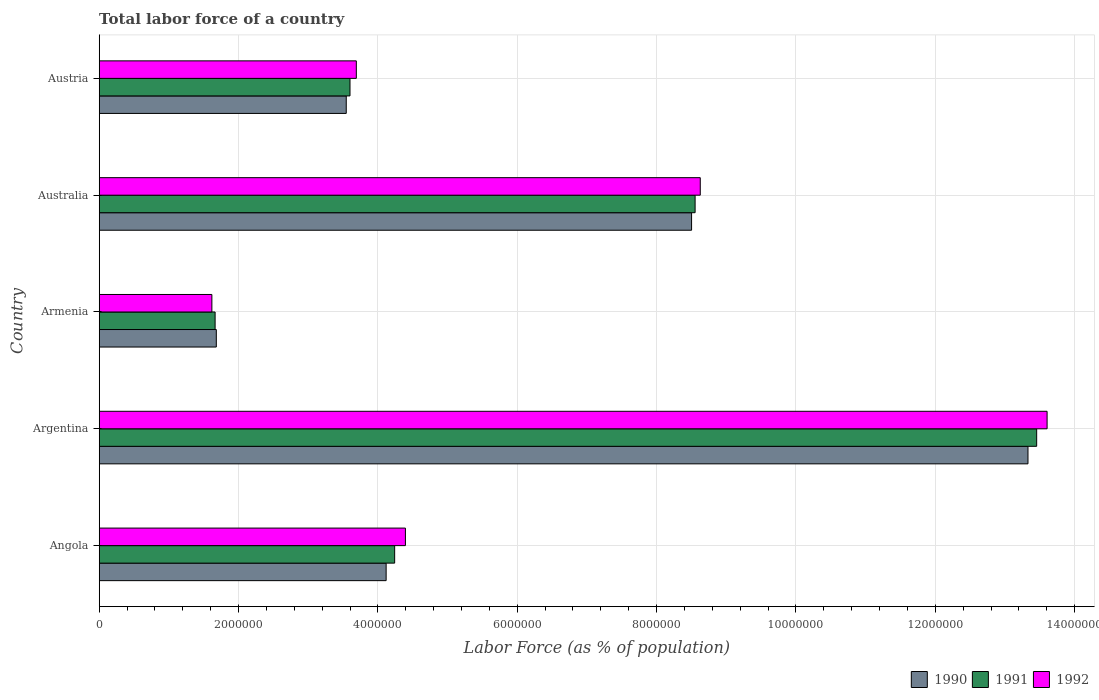Are the number of bars on each tick of the Y-axis equal?
Your answer should be compact. Yes. How many bars are there on the 4th tick from the top?
Ensure brevity in your answer.  3. What is the label of the 4th group of bars from the top?
Your answer should be very brief. Argentina. What is the percentage of labor force in 1991 in Angola?
Give a very brief answer. 4.24e+06. Across all countries, what is the maximum percentage of labor force in 1991?
Your answer should be very brief. 1.35e+07. Across all countries, what is the minimum percentage of labor force in 1992?
Offer a very short reply. 1.62e+06. In which country was the percentage of labor force in 1990 minimum?
Offer a very short reply. Armenia. What is the total percentage of labor force in 1991 in the graph?
Ensure brevity in your answer.  3.15e+07. What is the difference between the percentage of labor force in 1992 in Argentina and that in Australia?
Keep it short and to the point. 4.98e+06. What is the difference between the percentage of labor force in 1990 in Argentina and the percentage of labor force in 1991 in Angola?
Your answer should be very brief. 9.09e+06. What is the average percentage of labor force in 1992 per country?
Make the answer very short. 6.39e+06. What is the difference between the percentage of labor force in 1992 and percentage of labor force in 1991 in Angola?
Offer a very short reply. 1.55e+05. What is the ratio of the percentage of labor force in 1991 in Armenia to that in Austria?
Ensure brevity in your answer.  0.46. Is the percentage of labor force in 1990 in Australia less than that in Austria?
Provide a short and direct response. No. What is the difference between the highest and the second highest percentage of labor force in 1991?
Give a very brief answer. 4.90e+06. What is the difference between the highest and the lowest percentage of labor force in 1990?
Ensure brevity in your answer.  1.17e+07. What does the 2nd bar from the top in Angola represents?
Your response must be concise. 1991. What does the 2nd bar from the bottom in Armenia represents?
Keep it short and to the point. 1991. Is it the case that in every country, the sum of the percentage of labor force in 1990 and percentage of labor force in 1991 is greater than the percentage of labor force in 1992?
Provide a succinct answer. Yes. Are all the bars in the graph horizontal?
Make the answer very short. Yes. Are the values on the major ticks of X-axis written in scientific E-notation?
Provide a succinct answer. No. Does the graph contain any zero values?
Keep it short and to the point. No. How many legend labels are there?
Your answer should be very brief. 3. How are the legend labels stacked?
Your response must be concise. Horizontal. What is the title of the graph?
Offer a terse response. Total labor force of a country. Does "1973" appear as one of the legend labels in the graph?
Keep it short and to the point. No. What is the label or title of the X-axis?
Give a very brief answer. Labor Force (as % of population). What is the label or title of the Y-axis?
Provide a short and direct response. Country. What is the Labor Force (as % of population) in 1990 in Angola?
Offer a very short reply. 4.12e+06. What is the Labor Force (as % of population) in 1991 in Angola?
Your answer should be very brief. 4.24e+06. What is the Labor Force (as % of population) in 1992 in Angola?
Give a very brief answer. 4.40e+06. What is the Labor Force (as % of population) of 1990 in Argentina?
Provide a succinct answer. 1.33e+07. What is the Labor Force (as % of population) in 1991 in Argentina?
Offer a terse response. 1.35e+07. What is the Labor Force (as % of population) of 1992 in Argentina?
Your answer should be compact. 1.36e+07. What is the Labor Force (as % of population) in 1990 in Armenia?
Make the answer very short. 1.68e+06. What is the Labor Force (as % of population) of 1991 in Armenia?
Your answer should be very brief. 1.66e+06. What is the Labor Force (as % of population) in 1992 in Armenia?
Offer a very short reply. 1.62e+06. What is the Labor Force (as % of population) of 1990 in Australia?
Give a very brief answer. 8.50e+06. What is the Labor Force (as % of population) of 1991 in Australia?
Offer a very short reply. 8.55e+06. What is the Labor Force (as % of population) of 1992 in Australia?
Your response must be concise. 8.63e+06. What is the Labor Force (as % of population) of 1990 in Austria?
Your answer should be compact. 3.55e+06. What is the Labor Force (as % of population) in 1991 in Austria?
Your response must be concise. 3.60e+06. What is the Labor Force (as % of population) in 1992 in Austria?
Give a very brief answer. 3.69e+06. Across all countries, what is the maximum Labor Force (as % of population) of 1990?
Your response must be concise. 1.33e+07. Across all countries, what is the maximum Labor Force (as % of population) in 1991?
Offer a very short reply. 1.35e+07. Across all countries, what is the maximum Labor Force (as % of population) of 1992?
Offer a terse response. 1.36e+07. Across all countries, what is the minimum Labor Force (as % of population) in 1990?
Your answer should be compact. 1.68e+06. Across all countries, what is the minimum Labor Force (as % of population) of 1991?
Provide a short and direct response. 1.66e+06. Across all countries, what is the minimum Labor Force (as % of population) in 1992?
Provide a short and direct response. 1.62e+06. What is the total Labor Force (as % of population) in 1990 in the graph?
Your answer should be compact. 3.12e+07. What is the total Labor Force (as % of population) of 1991 in the graph?
Your answer should be very brief. 3.15e+07. What is the total Labor Force (as % of population) in 1992 in the graph?
Offer a terse response. 3.19e+07. What is the difference between the Labor Force (as % of population) of 1990 in Angola and that in Argentina?
Offer a very short reply. -9.21e+06. What is the difference between the Labor Force (as % of population) of 1991 in Angola and that in Argentina?
Your answer should be compact. -9.21e+06. What is the difference between the Labor Force (as % of population) of 1992 in Angola and that in Argentina?
Offer a terse response. -9.21e+06. What is the difference between the Labor Force (as % of population) in 1990 in Angola and that in Armenia?
Offer a terse response. 2.44e+06. What is the difference between the Labor Force (as % of population) of 1991 in Angola and that in Armenia?
Ensure brevity in your answer.  2.58e+06. What is the difference between the Labor Force (as % of population) in 1992 in Angola and that in Armenia?
Provide a succinct answer. 2.78e+06. What is the difference between the Labor Force (as % of population) in 1990 in Angola and that in Australia?
Give a very brief answer. -4.38e+06. What is the difference between the Labor Force (as % of population) of 1991 in Angola and that in Australia?
Your response must be concise. -4.31e+06. What is the difference between the Labor Force (as % of population) of 1992 in Angola and that in Australia?
Your answer should be very brief. -4.23e+06. What is the difference between the Labor Force (as % of population) in 1990 in Angola and that in Austria?
Ensure brevity in your answer.  5.73e+05. What is the difference between the Labor Force (as % of population) of 1991 in Angola and that in Austria?
Your answer should be very brief. 6.41e+05. What is the difference between the Labor Force (as % of population) in 1992 in Angola and that in Austria?
Your answer should be compact. 7.05e+05. What is the difference between the Labor Force (as % of population) in 1990 in Argentina and that in Armenia?
Ensure brevity in your answer.  1.17e+07. What is the difference between the Labor Force (as % of population) in 1991 in Argentina and that in Armenia?
Provide a short and direct response. 1.18e+07. What is the difference between the Labor Force (as % of population) of 1992 in Argentina and that in Armenia?
Your answer should be very brief. 1.20e+07. What is the difference between the Labor Force (as % of population) of 1990 in Argentina and that in Australia?
Make the answer very short. 4.83e+06. What is the difference between the Labor Force (as % of population) of 1991 in Argentina and that in Australia?
Provide a short and direct response. 4.90e+06. What is the difference between the Labor Force (as % of population) in 1992 in Argentina and that in Australia?
Offer a terse response. 4.98e+06. What is the difference between the Labor Force (as % of population) of 1990 in Argentina and that in Austria?
Your answer should be very brief. 9.79e+06. What is the difference between the Labor Force (as % of population) of 1991 in Argentina and that in Austria?
Give a very brief answer. 9.86e+06. What is the difference between the Labor Force (as % of population) in 1992 in Argentina and that in Austria?
Ensure brevity in your answer.  9.91e+06. What is the difference between the Labor Force (as % of population) of 1990 in Armenia and that in Australia?
Your response must be concise. -6.82e+06. What is the difference between the Labor Force (as % of population) in 1991 in Armenia and that in Australia?
Provide a succinct answer. -6.89e+06. What is the difference between the Labor Force (as % of population) in 1992 in Armenia and that in Australia?
Ensure brevity in your answer.  -7.01e+06. What is the difference between the Labor Force (as % of population) in 1990 in Armenia and that in Austria?
Give a very brief answer. -1.86e+06. What is the difference between the Labor Force (as % of population) in 1991 in Armenia and that in Austria?
Your response must be concise. -1.94e+06. What is the difference between the Labor Force (as % of population) in 1992 in Armenia and that in Austria?
Provide a short and direct response. -2.07e+06. What is the difference between the Labor Force (as % of population) of 1990 in Australia and that in Austria?
Your answer should be very brief. 4.96e+06. What is the difference between the Labor Force (as % of population) of 1991 in Australia and that in Austria?
Give a very brief answer. 4.95e+06. What is the difference between the Labor Force (as % of population) of 1992 in Australia and that in Austria?
Your response must be concise. 4.94e+06. What is the difference between the Labor Force (as % of population) in 1990 in Angola and the Labor Force (as % of population) in 1991 in Argentina?
Give a very brief answer. -9.34e+06. What is the difference between the Labor Force (as % of population) of 1990 in Angola and the Labor Force (as % of population) of 1992 in Argentina?
Your answer should be compact. -9.49e+06. What is the difference between the Labor Force (as % of population) in 1991 in Angola and the Labor Force (as % of population) in 1992 in Argentina?
Provide a short and direct response. -9.36e+06. What is the difference between the Labor Force (as % of population) in 1990 in Angola and the Labor Force (as % of population) in 1991 in Armenia?
Make the answer very short. 2.45e+06. What is the difference between the Labor Force (as % of population) of 1990 in Angola and the Labor Force (as % of population) of 1992 in Armenia?
Your response must be concise. 2.50e+06. What is the difference between the Labor Force (as % of population) in 1991 in Angola and the Labor Force (as % of population) in 1992 in Armenia?
Provide a succinct answer. 2.62e+06. What is the difference between the Labor Force (as % of population) in 1990 in Angola and the Labor Force (as % of population) in 1991 in Australia?
Your answer should be very brief. -4.43e+06. What is the difference between the Labor Force (as % of population) of 1990 in Angola and the Labor Force (as % of population) of 1992 in Australia?
Keep it short and to the point. -4.51e+06. What is the difference between the Labor Force (as % of population) in 1991 in Angola and the Labor Force (as % of population) in 1992 in Australia?
Keep it short and to the point. -4.39e+06. What is the difference between the Labor Force (as % of population) of 1990 in Angola and the Labor Force (as % of population) of 1991 in Austria?
Offer a very short reply. 5.19e+05. What is the difference between the Labor Force (as % of population) of 1990 in Angola and the Labor Force (as % of population) of 1992 in Austria?
Give a very brief answer. 4.28e+05. What is the difference between the Labor Force (as % of population) in 1991 in Angola and the Labor Force (as % of population) in 1992 in Austria?
Keep it short and to the point. 5.50e+05. What is the difference between the Labor Force (as % of population) of 1990 in Argentina and the Labor Force (as % of population) of 1991 in Armenia?
Offer a very short reply. 1.17e+07. What is the difference between the Labor Force (as % of population) of 1990 in Argentina and the Labor Force (as % of population) of 1992 in Armenia?
Make the answer very short. 1.17e+07. What is the difference between the Labor Force (as % of population) in 1991 in Argentina and the Labor Force (as % of population) in 1992 in Armenia?
Keep it short and to the point. 1.18e+07. What is the difference between the Labor Force (as % of population) in 1990 in Argentina and the Labor Force (as % of population) in 1991 in Australia?
Keep it short and to the point. 4.78e+06. What is the difference between the Labor Force (as % of population) in 1990 in Argentina and the Labor Force (as % of population) in 1992 in Australia?
Offer a very short reply. 4.70e+06. What is the difference between the Labor Force (as % of population) in 1991 in Argentina and the Labor Force (as % of population) in 1992 in Australia?
Provide a succinct answer. 4.83e+06. What is the difference between the Labor Force (as % of population) of 1990 in Argentina and the Labor Force (as % of population) of 1991 in Austria?
Offer a terse response. 9.73e+06. What is the difference between the Labor Force (as % of population) in 1990 in Argentina and the Labor Force (as % of population) in 1992 in Austria?
Offer a very short reply. 9.64e+06. What is the difference between the Labor Force (as % of population) in 1991 in Argentina and the Labor Force (as % of population) in 1992 in Austria?
Provide a succinct answer. 9.77e+06. What is the difference between the Labor Force (as % of population) in 1990 in Armenia and the Labor Force (as % of population) in 1991 in Australia?
Your answer should be very brief. -6.87e+06. What is the difference between the Labor Force (as % of population) in 1990 in Armenia and the Labor Force (as % of population) in 1992 in Australia?
Provide a short and direct response. -6.95e+06. What is the difference between the Labor Force (as % of population) in 1991 in Armenia and the Labor Force (as % of population) in 1992 in Australia?
Your answer should be very brief. -6.96e+06. What is the difference between the Labor Force (as % of population) of 1990 in Armenia and the Labor Force (as % of population) of 1991 in Austria?
Your response must be concise. -1.92e+06. What is the difference between the Labor Force (as % of population) of 1990 in Armenia and the Labor Force (as % of population) of 1992 in Austria?
Provide a short and direct response. -2.01e+06. What is the difference between the Labor Force (as % of population) of 1991 in Armenia and the Labor Force (as % of population) of 1992 in Austria?
Ensure brevity in your answer.  -2.03e+06. What is the difference between the Labor Force (as % of population) of 1990 in Australia and the Labor Force (as % of population) of 1991 in Austria?
Your answer should be very brief. 4.90e+06. What is the difference between the Labor Force (as % of population) in 1990 in Australia and the Labor Force (as % of population) in 1992 in Austria?
Your answer should be compact. 4.81e+06. What is the difference between the Labor Force (as % of population) in 1991 in Australia and the Labor Force (as % of population) in 1992 in Austria?
Make the answer very short. 4.86e+06. What is the average Labor Force (as % of population) in 1990 per country?
Make the answer very short. 6.24e+06. What is the average Labor Force (as % of population) of 1991 per country?
Offer a very short reply. 6.30e+06. What is the average Labor Force (as % of population) of 1992 per country?
Offer a very short reply. 6.39e+06. What is the difference between the Labor Force (as % of population) in 1990 and Labor Force (as % of population) in 1991 in Angola?
Provide a short and direct response. -1.22e+05. What is the difference between the Labor Force (as % of population) of 1990 and Labor Force (as % of population) of 1992 in Angola?
Your answer should be compact. -2.77e+05. What is the difference between the Labor Force (as % of population) in 1991 and Labor Force (as % of population) in 1992 in Angola?
Ensure brevity in your answer.  -1.55e+05. What is the difference between the Labor Force (as % of population) of 1990 and Labor Force (as % of population) of 1991 in Argentina?
Ensure brevity in your answer.  -1.25e+05. What is the difference between the Labor Force (as % of population) in 1990 and Labor Force (as % of population) in 1992 in Argentina?
Provide a succinct answer. -2.74e+05. What is the difference between the Labor Force (as % of population) of 1991 and Labor Force (as % of population) of 1992 in Argentina?
Provide a succinct answer. -1.50e+05. What is the difference between the Labor Force (as % of population) of 1990 and Labor Force (as % of population) of 1991 in Armenia?
Your answer should be compact. 1.74e+04. What is the difference between the Labor Force (as % of population) of 1990 and Labor Force (as % of population) of 1992 in Armenia?
Ensure brevity in your answer.  6.37e+04. What is the difference between the Labor Force (as % of population) of 1991 and Labor Force (as % of population) of 1992 in Armenia?
Provide a short and direct response. 4.64e+04. What is the difference between the Labor Force (as % of population) in 1990 and Labor Force (as % of population) in 1991 in Australia?
Offer a terse response. -5.07e+04. What is the difference between the Labor Force (as % of population) of 1990 and Labor Force (as % of population) of 1992 in Australia?
Keep it short and to the point. -1.25e+05. What is the difference between the Labor Force (as % of population) in 1991 and Labor Force (as % of population) in 1992 in Australia?
Ensure brevity in your answer.  -7.41e+04. What is the difference between the Labor Force (as % of population) of 1990 and Labor Force (as % of population) of 1991 in Austria?
Ensure brevity in your answer.  -5.39e+04. What is the difference between the Labor Force (as % of population) of 1990 and Labor Force (as % of population) of 1992 in Austria?
Offer a very short reply. -1.45e+05. What is the difference between the Labor Force (as % of population) in 1991 and Labor Force (as % of population) in 1992 in Austria?
Provide a succinct answer. -9.07e+04. What is the ratio of the Labor Force (as % of population) of 1990 in Angola to that in Argentina?
Keep it short and to the point. 0.31. What is the ratio of the Labor Force (as % of population) of 1991 in Angola to that in Argentina?
Your answer should be compact. 0.32. What is the ratio of the Labor Force (as % of population) in 1992 in Angola to that in Argentina?
Keep it short and to the point. 0.32. What is the ratio of the Labor Force (as % of population) in 1990 in Angola to that in Armenia?
Provide a short and direct response. 2.45. What is the ratio of the Labor Force (as % of population) in 1991 in Angola to that in Armenia?
Provide a short and direct response. 2.55. What is the ratio of the Labor Force (as % of population) in 1992 in Angola to that in Armenia?
Offer a terse response. 2.72. What is the ratio of the Labor Force (as % of population) of 1990 in Angola to that in Australia?
Your response must be concise. 0.48. What is the ratio of the Labor Force (as % of population) of 1991 in Angola to that in Australia?
Make the answer very short. 0.5. What is the ratio of the Labor Force (as % of population) of 1992 in Angola to that in Australia?
Offer a very short reply. 0.51. What is the ratio of the Labor Force (as % of population) of 1990 in Angola to that in Austria?
Offer a terse response. 1.16. What is the ratio of the Labor Force (as % of population) in 1991 in Angola to that in Austria?
Give a very brief answer. 1.18. What is the ratio of the Labor Force (as % of population) of 1992 in Angola to that in Austria?
Offer a very short reply. 1.19. What is the ratio of the Labor Force (as % of population) in 1990 in Argentina to that in Armenia?
Offer a very short reply. 7.93. What is the ratio of the Labor Force (as % of population) in 1991 in Argentina to that in Armenia?
Offer a terse response. 8.09. What is the ratio of the Labor Force (as % of population) of 1992 in Argentina to that in Armenia?
Offer a terse response. 8.41. What is the ratio of the Labor Force (as % of population) in 1990 in Argentina to that in Australia?
Your answer should be very brief. 1.57. What is the ratio of the Labor Force (as % of population) in 1991 in Argentina to that in Australia?
Your response must be concise. 1.57. What is the ratio of the Labor Force (as % of population) of 1992 in Argentina to that in Australia?
Ensure brevity in your answer.  1.58. What is the ratio of the Labor Force (as % of population) of 1990 in Argentina to that in Austria?
Offer a very short reply. 3.76. What is the ratio of the Labor Force (as % of population) of 1991 in Argentina to that in Austria?
Give a very brief answer. 3.74. What is the ratio of the Labor Force (as % of population) in 1992 in Argentina to that in Austria?
Provide a short and direct response. 3.69. What is the ratio of the Labor Force (as % of population) of 1990 in Armenia to that in Australia?
Offer a terse response. 0.2. What is the ratio of the Labor Force (as % of population) of 1991 in Armenia to that in Australia?
Your answer should be compact. 0.19. What is the ratio of the Labor Force (as % of population) of 1992 in Armenia to that in Australia?
Offer a terse response. 0.19. What is the ratio of the Labor Force (as % of population) of 1990 in Armenia to that in Austria?
Your answer should be compact. 0.47. What is the ratio of the Labor Force (as % of population) of 1991 in Armenia to that in Austria?
Your answer should be compact. 0.46. What is the ratio of the Labor Force (as % of population) of 1992 in Armenia to that in Austria?
Your answer should be very brief. 0.44. What is the ratio of the Labor Force (as % of population) in 1990 in Australia to that in Austria?
Provide a succinct answer. 2.4. What is the ratio of the Labor Force (as % of population) in 1991 in Australia to that in Austria?
Keep it short and to the point. 2.38. What is the ratio of the Labor Force (as % of population) of 1992 in Australia to that in Austria?
Make the answer very short. 2.34. What is the difference between the highest and the second highest Labor Force (as % of population) of 1990?
Your answer should be compact. 4.83e+06. What is the difference between the highest and the second highest Labor Force (as % of population) of 1991?
Provide a short and direct response. 4.90e+06. What is the difference between the highest and the second highest Labor Force (as % of population) of 1992?
Your answer should be very brief. 4.98e+06. What is the difference between the highest and the lowest Labor Force (as % of population) in 1990?
Offer a very short reply. 1.17e+07. What is the difference between the highest and the lowest Labor Force (as % of population) in 1991?
Make the answer very short. 1.18e+07. What is the difference between the highest and the lowest Labor Force (as % of population) in 1992?
Keep it short and to the point. 1.20e+07. 